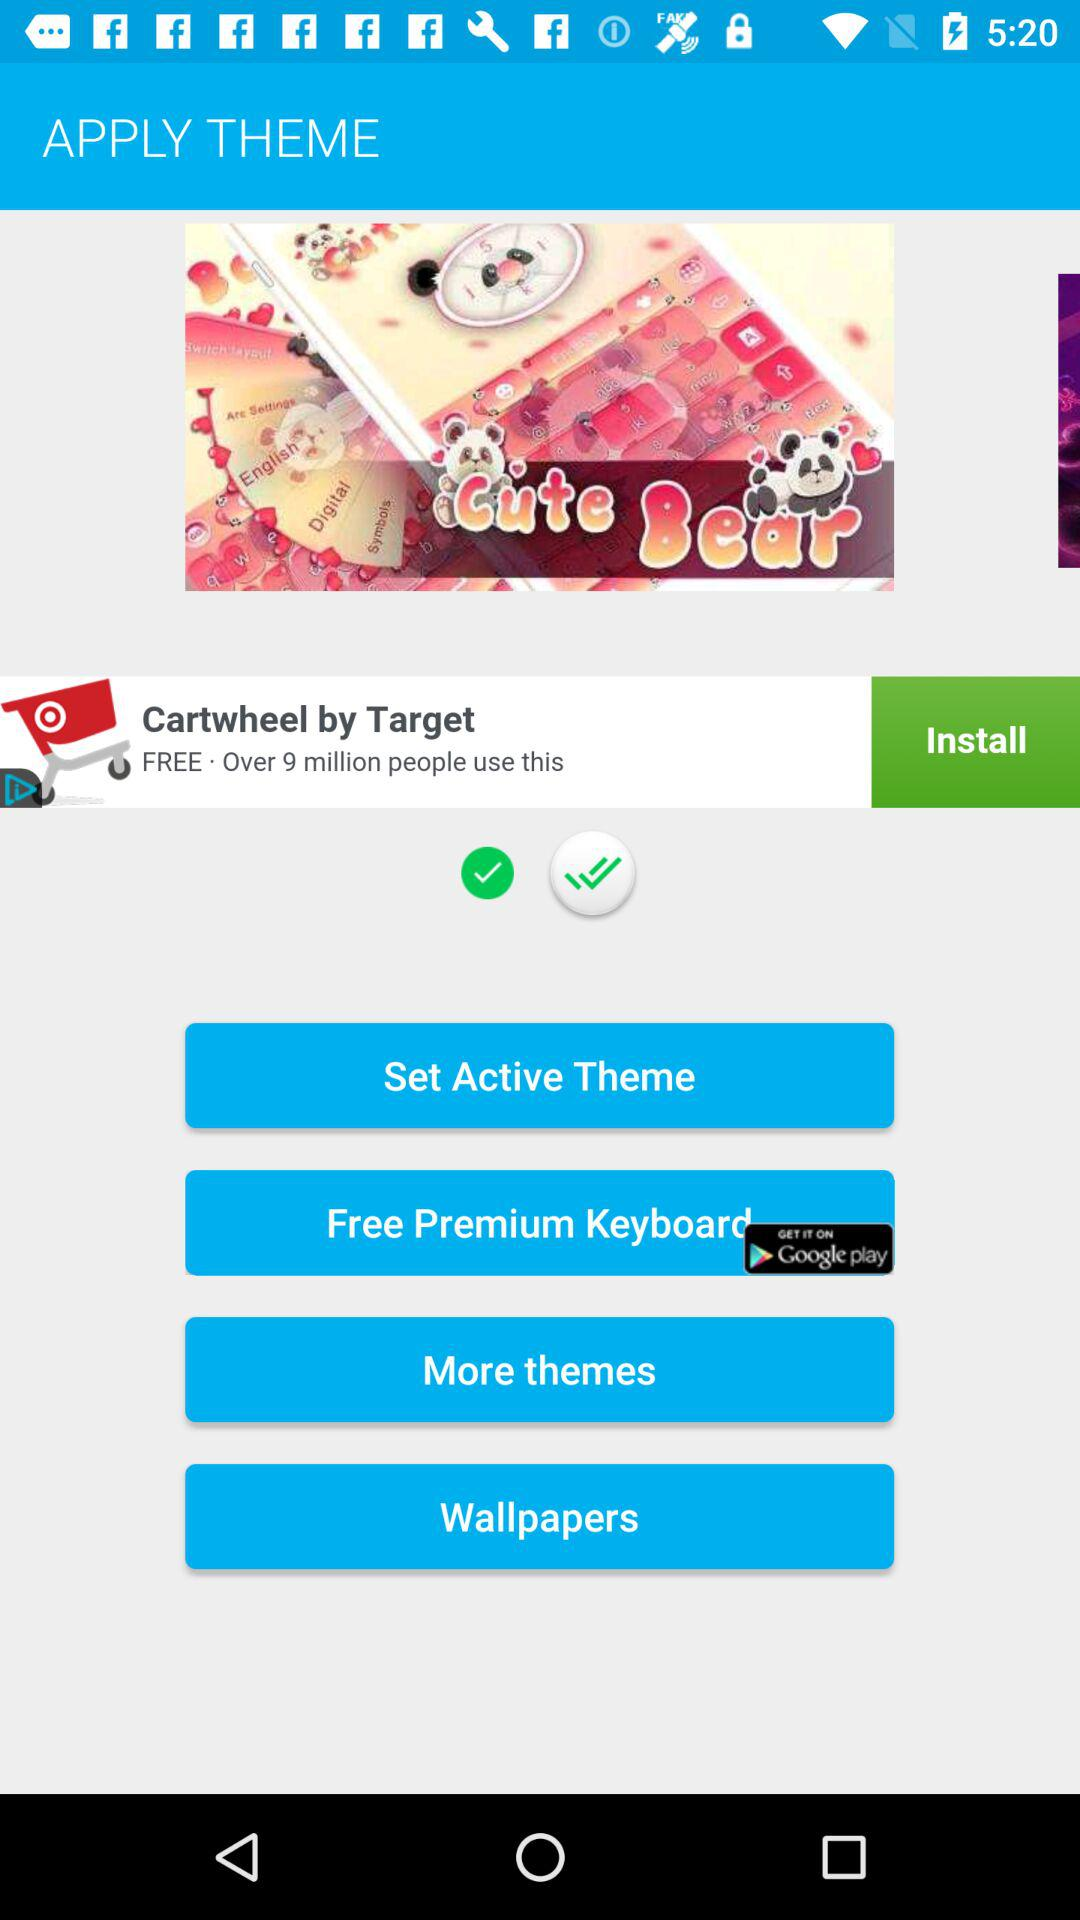How many checkmarks are there?
Answer the question using a single word or phrase. 2 